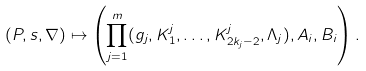<formula> <loc_0><loc_0><loc_500><loc_500>( P , s , \nabla ) \mapsto \left ( \prod _ { j = 1 } ^ { m } ( g _ { j } , K _ { 1 } ^ { j } , \dots , K _ { 2 k _ { j } - 2 } ^ { j } , \Lambda _ { j } ) , A _ { i } , B _ { i } \right ) .</formula> 